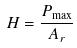<formula> <loc_0><loc_0><loc_500><loc_500>H = \frac { P _ { \max } } { A _ { r } }</formula> 